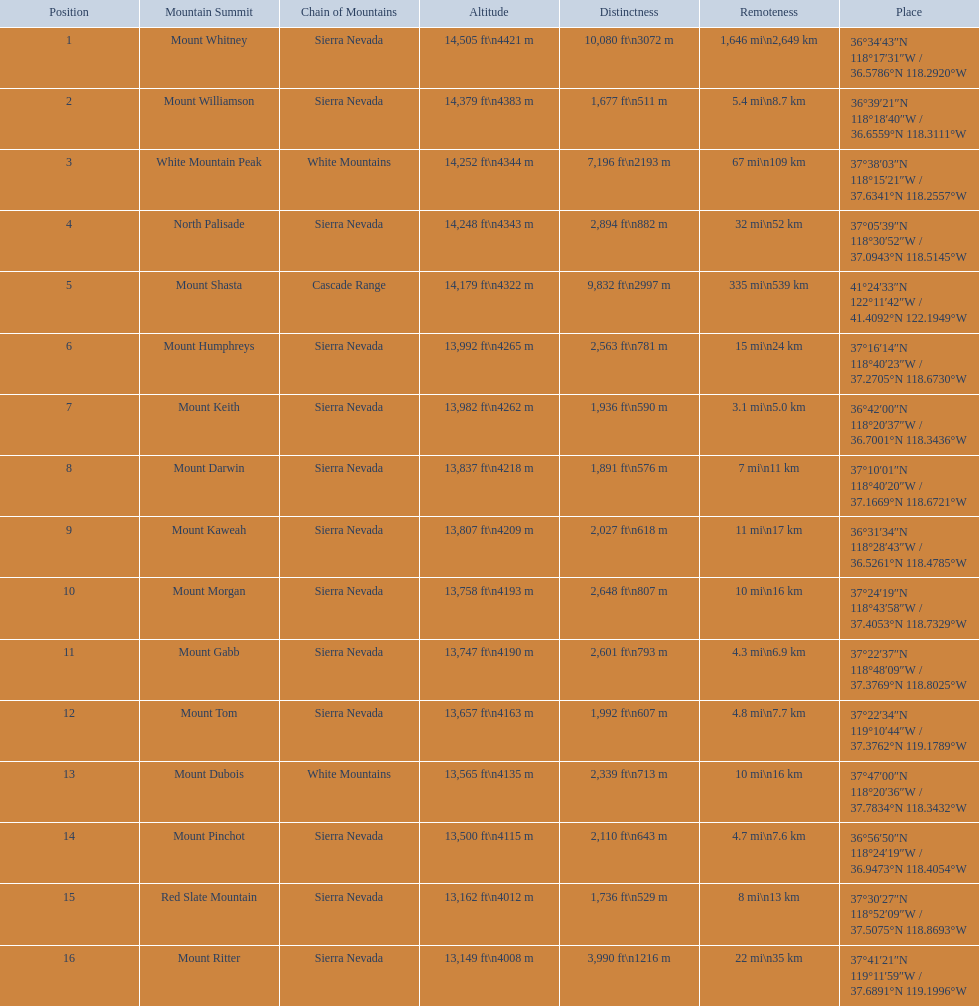Which are the highest mountain peaks in california? Mount Whitney, Mount Williamson, White Mountain Peak, North Palisade, Mount Shasta, Mount Humphreys, Mount Keith, Mount Darwin, Mount Kaweah, Mount Morgan, Mount Gabb, Mount Tom, Mount Dubois, Mount Pinchot, Red Slate Mountain, Mount Ritter. Of those, which are not in the sierra nevada range? White Mountain Peak, Mount Shasta, Mount Dubois. Of the mountains not in the sierra nevada range, which is the only mountain in the cascades? Mount Shasta. 